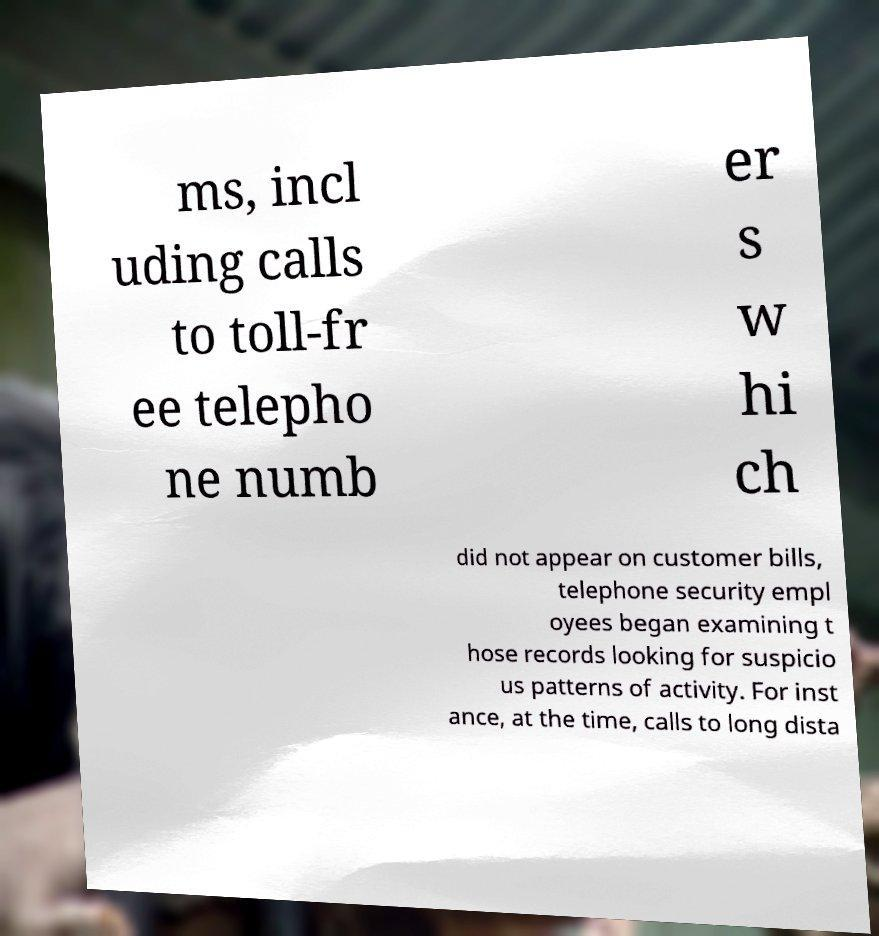Can you read and provide the text displayed in the image?This photo seems to have some interesting text. Can you extract and type it out for me? ms, incl uding calls to toll-fr ee telepho ne numb er s w hi ch did not appear on customer bills, telephone security empl oyees began examining t hose records looking for suspicio us patterns of activity. For inst ance, at the time, calls to long dista 